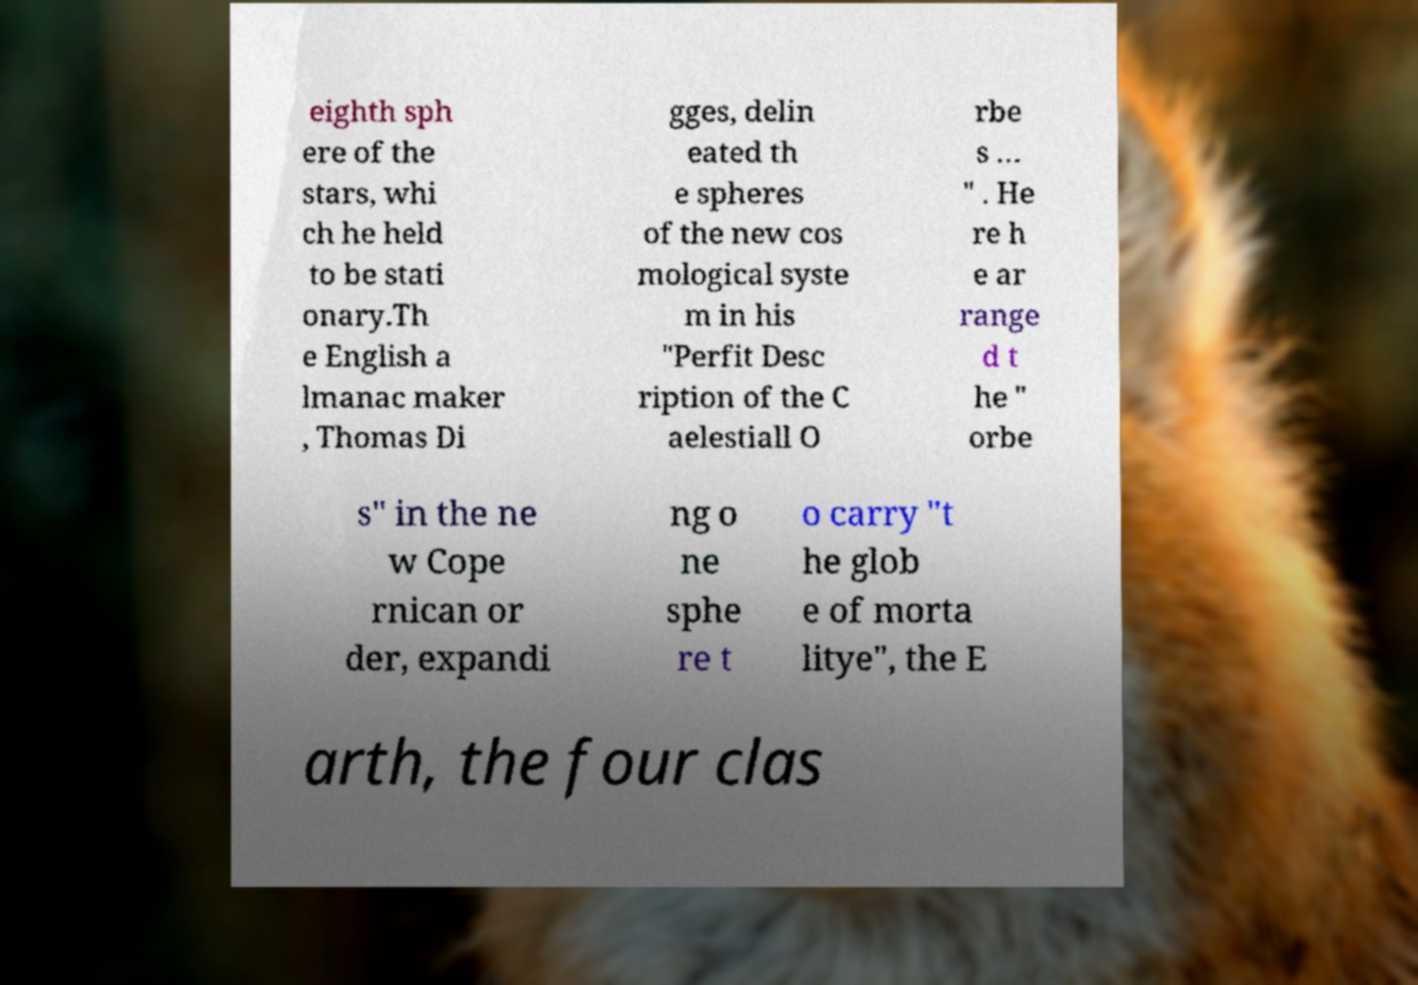Could you extract and type out the text from this image? eighth sph ere of the stars, whi ch he held to be stati onary.Th e English a lmanac maker , Thomas Di gges, delin eated th e spheres of the new cos mological syste m in his "Perfit Desc ription of the C aelestiall O rbe s … " . He re h e ar range d t he " orbe s" in the ne w Cope rnican or der, expandi ng o ne sphe re t o carry "t he glob e of morta litye", the E arth, the four clas 